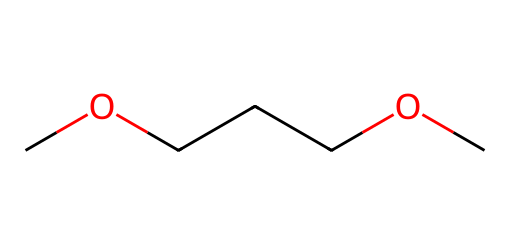what is the name of this chemical? The SMILES representation corresponds to polyethylene oxide, as inferred from the repeating -O- units and the structure observed.
Answer: polyethylene oxide how many carbon atoms are in the structure? By examining the SMILES notation, there are three carbon atoms indicated in the backbone (C(COC)COC), which are evident in the structure.
Answer: three does this chemical contain oxygen? The structure contains several -O- groups in conjunction with the carbon atoms, indicating the presence of oxygen in its molecular composition.
Answer: yes what type of fluid does polyethylene oxide belong to? Polyethylene oxide is characterized as a Non-Newtonian fluid due to its viscoelastic properties that change under stress, which is a notable feature of such fluids.
Answer: Non-Newtonian explain why polyethylene oxide can exhibit viscoelastic behavior? Polyethylene oxide has a high molecular weight and adopts chain entanglements which contribute to its viscoelastic behavior; under different stress conditions, it can behave like a solid or a liquid, depending on the applied force, as a result of its polymeric structure.
Answer: chain entanglements what effect does temperature have on the viscosity of polyethylene oxide solutions? The viscosity of polyethylene oxide solutions decreases with increasing temperature, due to the increased molecular motion which reduces the intermolecular interactions within the fluid, affecting its flow characteristics.
Answer: decreases how does polyethylene oxide contribute to the functionality of campaign materials? Polyethylene oxide enhances the viscosity and provides controlled release properties in promotional materials, improving how these materials spread and adhere while maintaining the desired texture and stability.
Answer: improves viscosity 